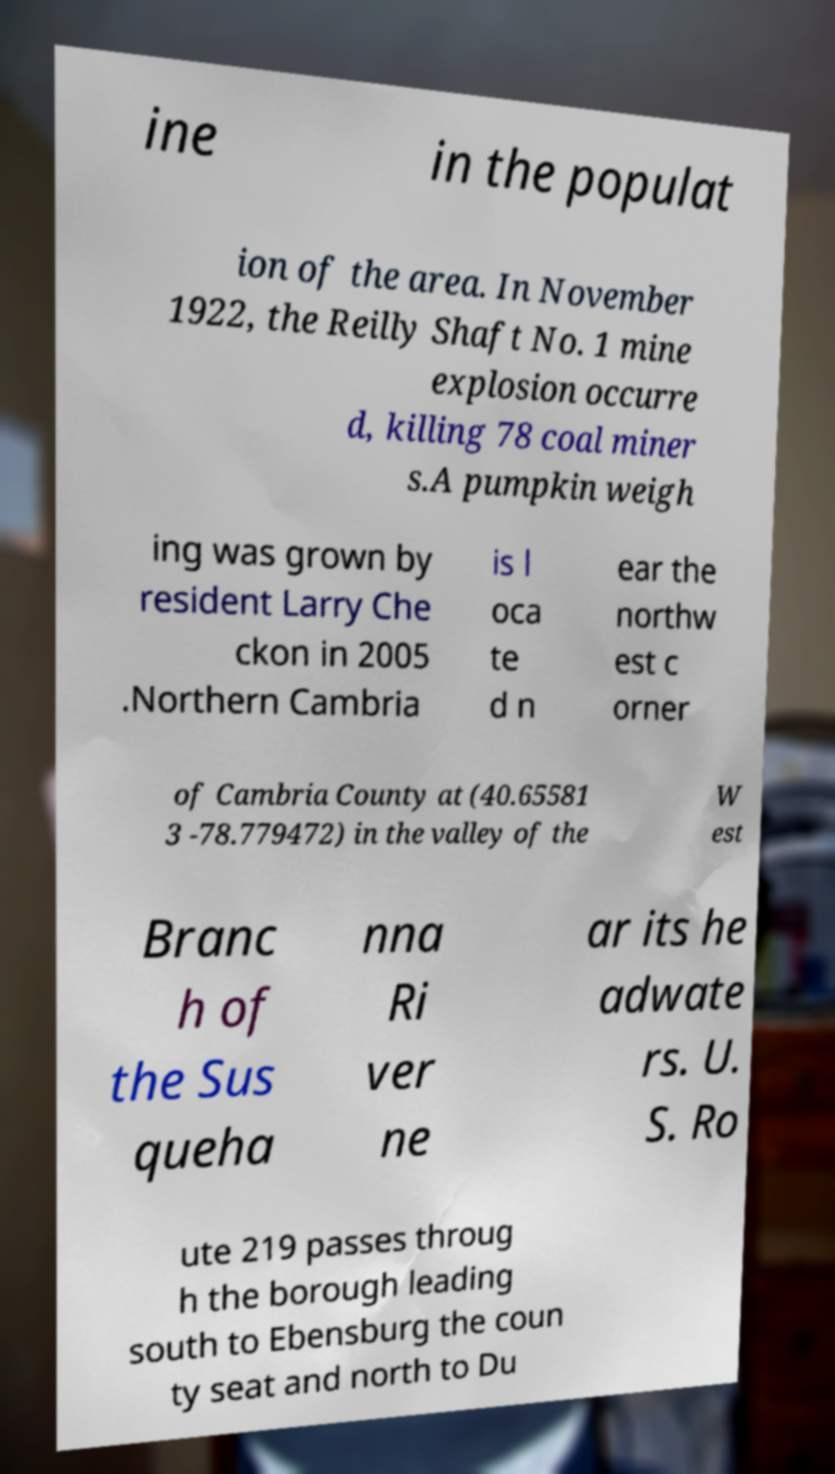Please read and relay the text visible in this image. What does it say? ine in the populat ion of the area. In November 1922, the Reilly Shaft No. 1 mine explosion occurre d, killing 78 coal miner s.A pumpkin weigh ing was grown by resident Larry Che ckon in 2005 .Northern Cambria is l oca te d n ear the northw est c orner of Cambria County at (40.65581 3 -78.779472) in the valley of the W est Branc h of the Sus queha nna Ri ver ne ar its he adwate rs. U. S. Ro ute 219 passes throug h the borough leading south to Ebensburg the coun ty seat and north to Du 